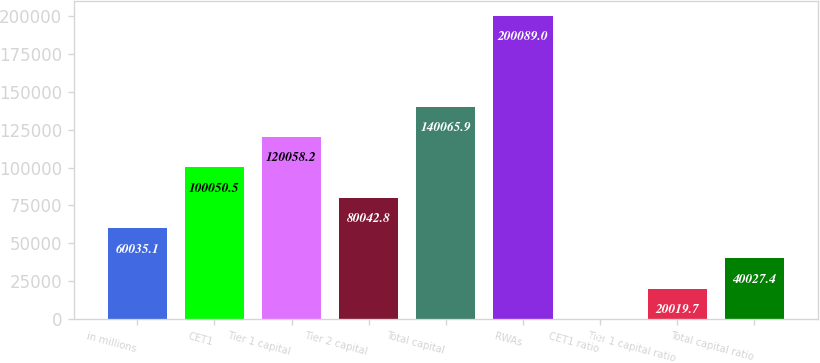Convert chart. <chart><loc_0><loc_0><loc_500><loc_500><bar_chart><fcel>in millions<fcel>CET1<fcel>Tier 1 capital<fcel>Tier 2 capital<fcel>Total capital<fcel>RWAs<fcel>CET1 ratio<fcel>Tier 1 capital ratio<fcel>Total capital ratio<nl><fcel>60035.1<fcel>100050<fcel>120058<fcel>80042.8<fcel>140066<fcel>200089<fcel>12<fcel>20019.7<fcel>40027.4<nl></chart> 